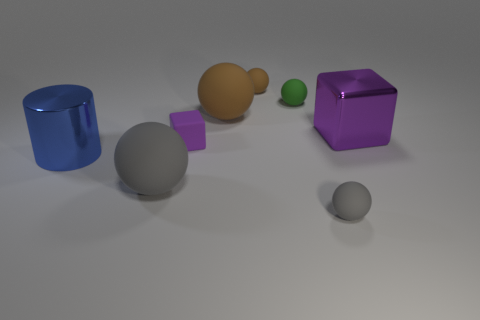Subtract all small gray spheres. How many spheres are left? 4 Add 2 big blue metal cylinders. How many objects exist? 10 Subtract 1 spheres. How many spheres are left? 4 Subtract all green cylinders. How many brown spheres are left? 2 Subtract all brown balls. How many balls are left? 3 Subtract all cylinders. How many objects are left? 7 Subtract all red balls. Subtract all red cubes. How many balls are left? 5 Add 3 large blue rubber balls. How many large blue rubber balls exist? 3 Subtract 0 cyan cylinders. How many objects are left? 8 Subtract all purple things. Subtract all shiny cylinders. How many objects are left? 5 